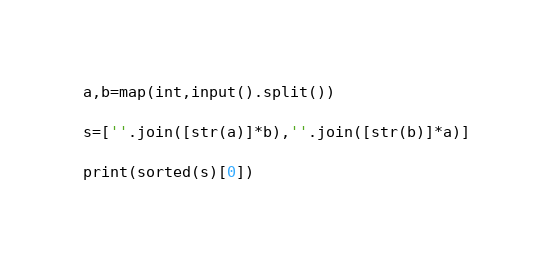<code> <loc_0><loc_0><loc_500><loc_500><_Python_>a,b=map(int,input().split())

s=[''.join([str(a)]*b),''.join([str(b)]*a)]

print(sorted(s)[0])</code> 